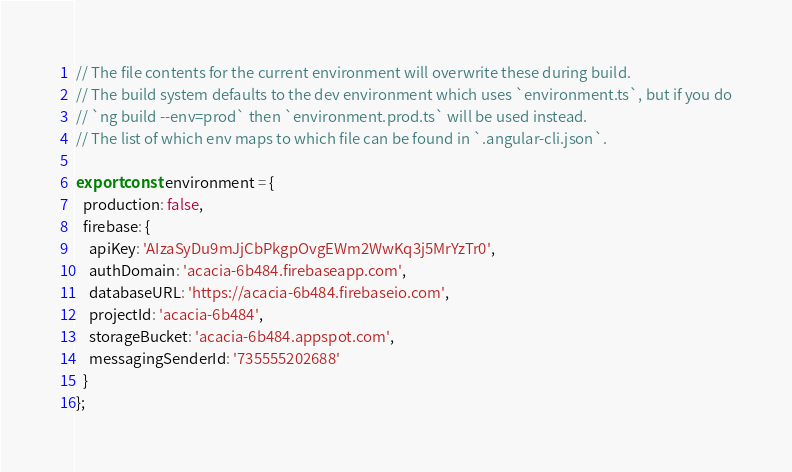<code> <loc_0><loc_0><loc_500><loc_500><_TypeScript_>// The file contents for the current environment will overwrite these during build.
// The build system defaults to the dev environment which uses `environment.ts`, but if you do
// `ng build --env=prod` then `environment.prod.ts` will be used instead.
// The list of which env maps to which file can be found in `.angular-cli.json`.

export const environment = {
  production: false,
  firebase: {
    apiKey: 'AIzaSyDu9mJjCbPkgpOvgEWm2WwKq3j5MrYzTr0',
    authDomain: 'acacia-6b484.firebaseapp.com',
    databaseURL: 'https://acacia-6b484.firebaseio.com',
    projectId: 'acacia-6b484',
    storageBucket: 'acacia-6b484.appspot.com',
    messagingSenderId: '735555202688'
  }
};
</code> 